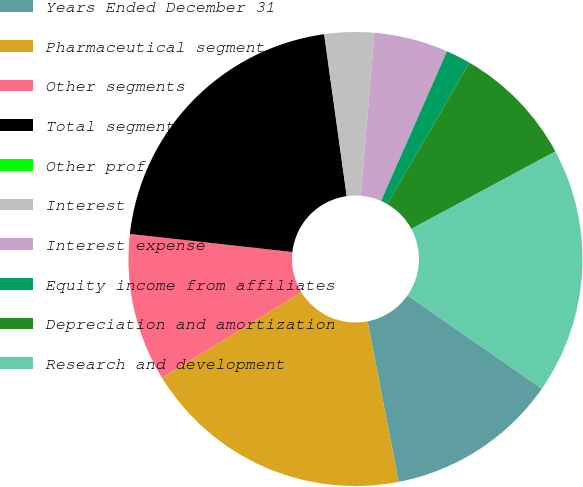<chart> <loc_0><loc_0><loc_500><loc_500><pie_chart><fcel>Years Ended December 31<fcel>Pharmaceutical segment<fcel>Other segments<fcel>Total segment profits<fcel>Other profits<fcel>Interest income<fcel>Interest expense<fcel>Equity income from affiliates<fcel>Depreciation and amortization<fcel>Research and development<nl><fcel>12.28%<fcel>19.28%<fcel>10.53%<fcel>21.03%<fcel>0.02%<fcel>3.52%<fcel>5.27%<fcel>1.77%<fcel>8.77%<fcel>17.53%<nl></chart> 